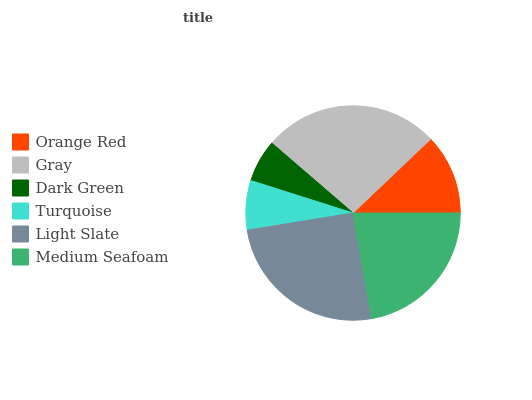Is Dark Green the minimum?
Answer yes or no. Yes. Is Gray the maximum?
Answer yes or no. Yes. Is Gray the minimum?
Answer yes or no. No. Is Dark Green the maximum?
Answer yes or no. No. Is Gray greater than Dark Green?
Answer yes or no. Yes. Is Dark Green less than Gray?
Answer yes or no. Yes. Is Dark Green greater than Gray?
Answer yes or no. No. Is Gray less than Dark Green?
Answer yes or no. No. Is Medium Seafoam the high median?
Answer yes or no. Yes. Is Orange Red the low median?
Answer yes or no. Yes. Is Turquoise the high median?
Answer yes or no. No. Is Turquoise the low median?
Answer yes or no. No. 